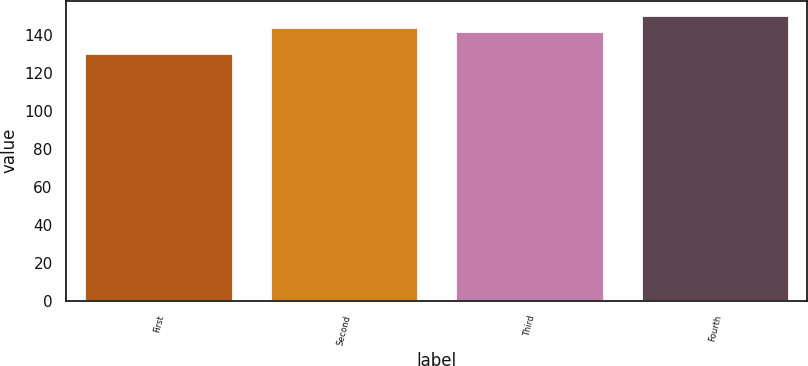Convert chart to OTSL. <chart><loc_0><loc_0><loc_500><loc_500><bar_chart><fcel>First<fcel>Second<fcel>Third<fcel>Fourth<nl><fcel>130.11<fcel>144.06<fcel>142.04<fcel>150.34<nl></chart> 